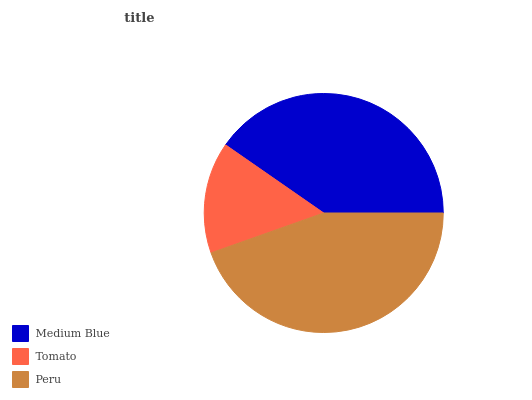Is Tomato the minimum?
Answer yes or no. Yes. Is Peru the maximum?
Answer yes or no. Yes. Is Peru the minimum?
Answer yes or no. No. Is Tomato the maximum?
Answer yes or no. No. Is Peru greater than Tomato?
Answer yes or no. Yes. Is Tomato less than Peru?
Answer yes or no. Yes. Is Tomato greater than Peru?
Answer yes or no. No. Is Peru less than Tomato?
Answer yes or no. No. Is Medium Blue the high median?
Answer yes or no. Yes. Is Medium Blue the low median?
Answer yes or no. Yes. Is Peru the high median?
Answer yes or no. No. Is Tomato the low median?
Answer yes or no. No. 